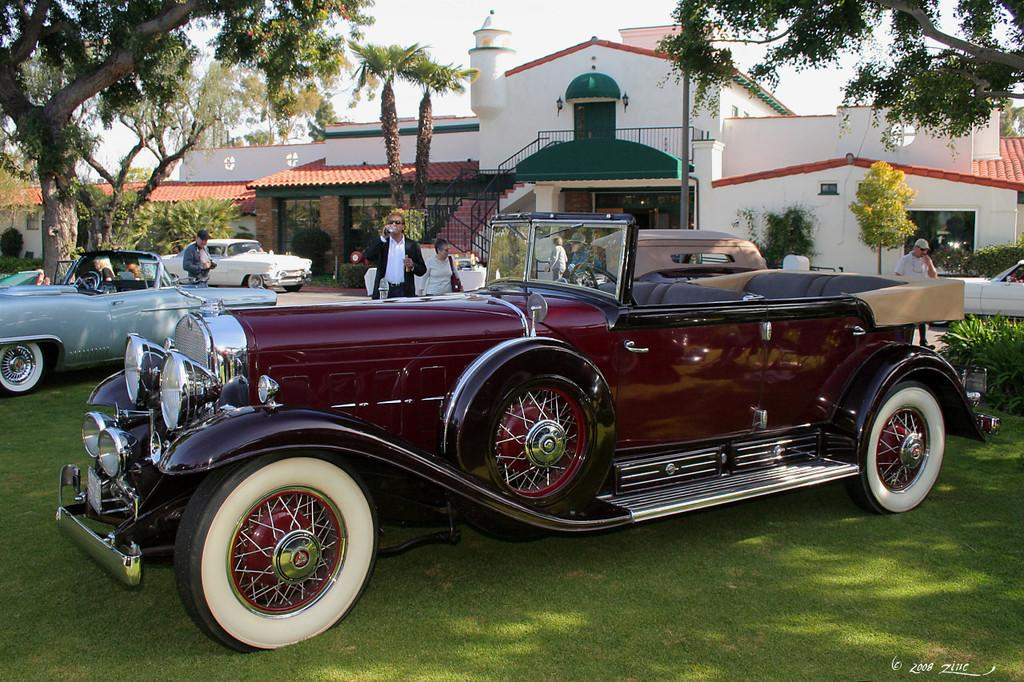What type of structures are visible in the image? There are houses in the image. What architectural feature can be seen in the image? There are stairs and a railing in the image. What type of vegetation is present in the image? There are trees in the image. What mode of transportation can be seen in the image? There are vehicles in the image. Are there any living beings in the image? Yes, there are people in the image. What is visible in the background of the image? The sky is visible in the image. Where are the bushes located in the image? There are no bushes present in the image. What type of furniture can be seen in the image? There is no furniture present in the image. 